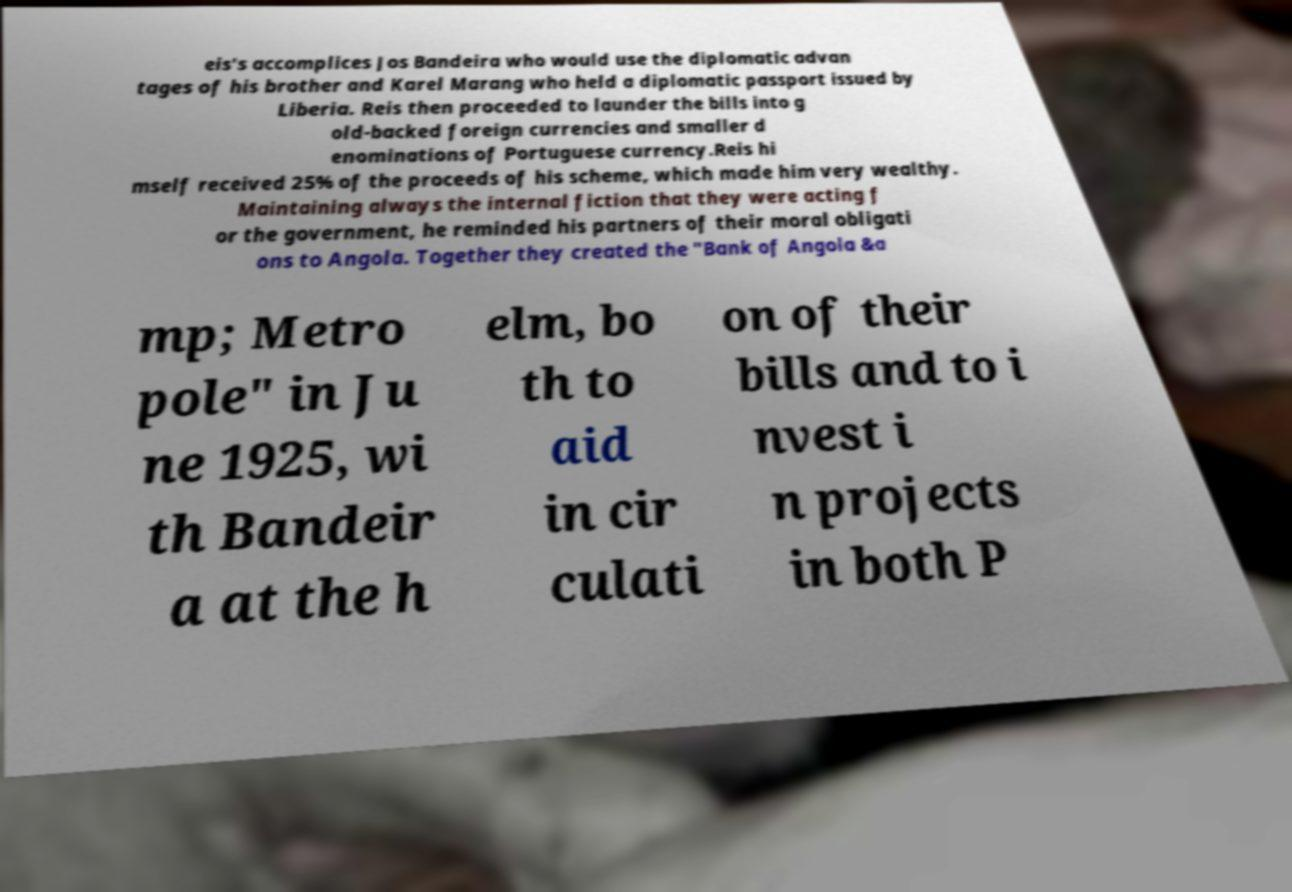There's text embedded in this image that I need extracted. Can you transcribe it verbatim? eis's accomplices Jos Bandeira who would use the diplomatic advan tages of his brother and Karel Marang who held a diplomatic passport issued by Liberia. Reis then proceeded to launder the bills into g old-backed foreign currencies and smaller d enominations of Portuguese currency.Reis hi mself received 25% of the proceeds of his scheme, which made him very wealthy. Maintaining always the internal fiction that they were acting f or the government, he reminded his partners of their moral obligati ons to Angola. Together they created the "Bank of Angola &a mp; Metro pole" in Ju ne 1925, wi th Bandeir a at the h elm, bo th to aid in cir culati on of their bills and to i nvest i n projects in both P 